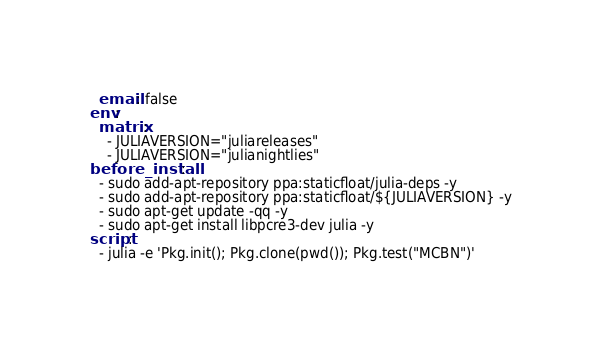<code> <loc_0><loc_0><loc_500><loc_500><_YAML_>  email: false
env:
  matrix:
    - JULIAVERSION="juliareleases"
    - JULIAVERSION="julianightlies"
before_install:
  - sudo add-apt-repository ppa:staticfloat/julia-deps -y
  - sudo add-apt-repository ppa:staticfloat/${JULIAVERSION} -y
  - sudo apt-get update -qq -y
  - sudo apt-get install libpcre3-dev julia -y
script:
  - julia -e 'Pkg.init(); Pkg.clone(pwd()); Pkg.test("MCBN")'
</code> 